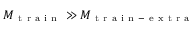<formula> <loc_0><loc_0><loc_500><loc_500>M _ { t r a i n } \gg M _ { t r a i n - e x t r a }</formula> 